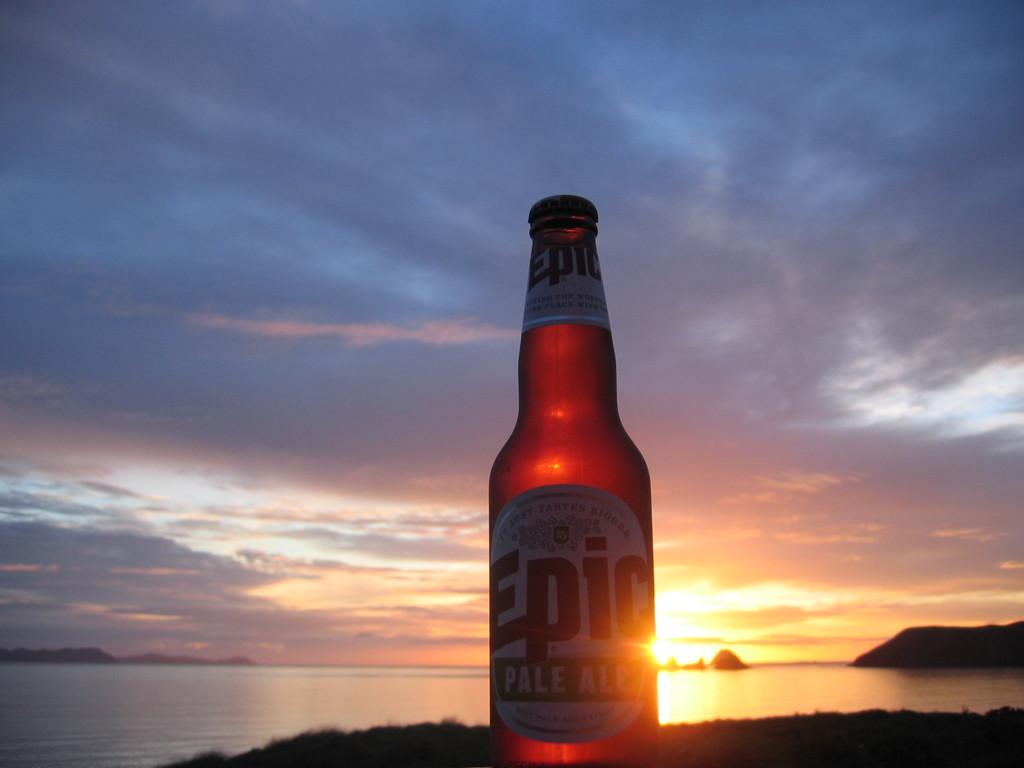What brand of beer is in the bottle?
Keep it short and to the point. Epic. Is epic a pale ale?
Provide a succinct answer. Yes. 